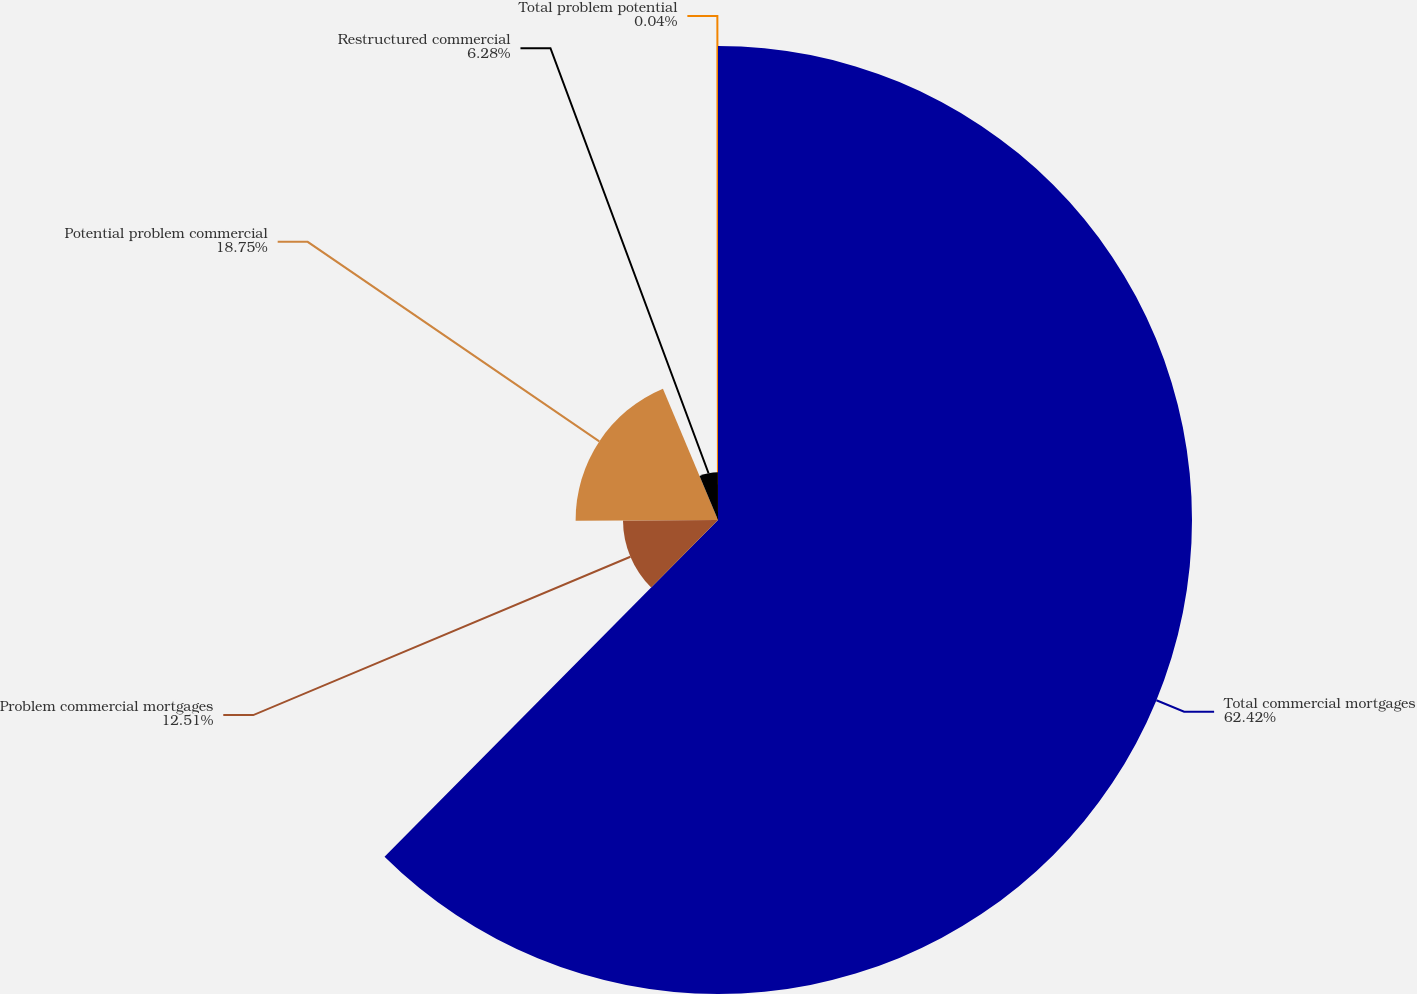<chart> <loc_0><loc_0><loc_500><loc_500><pie_chart><fcel>Total commercial mortgages<fcel>Problem commercial mortgages<fcel>Potential problem commercial<fcel>Restructured commercial<fcel>Total problem potential<nl><fcel>62.42%<fcel>12.51%<fcel>18.75%<fcel>6.28%<fcel>0.04%<nl></chart> 